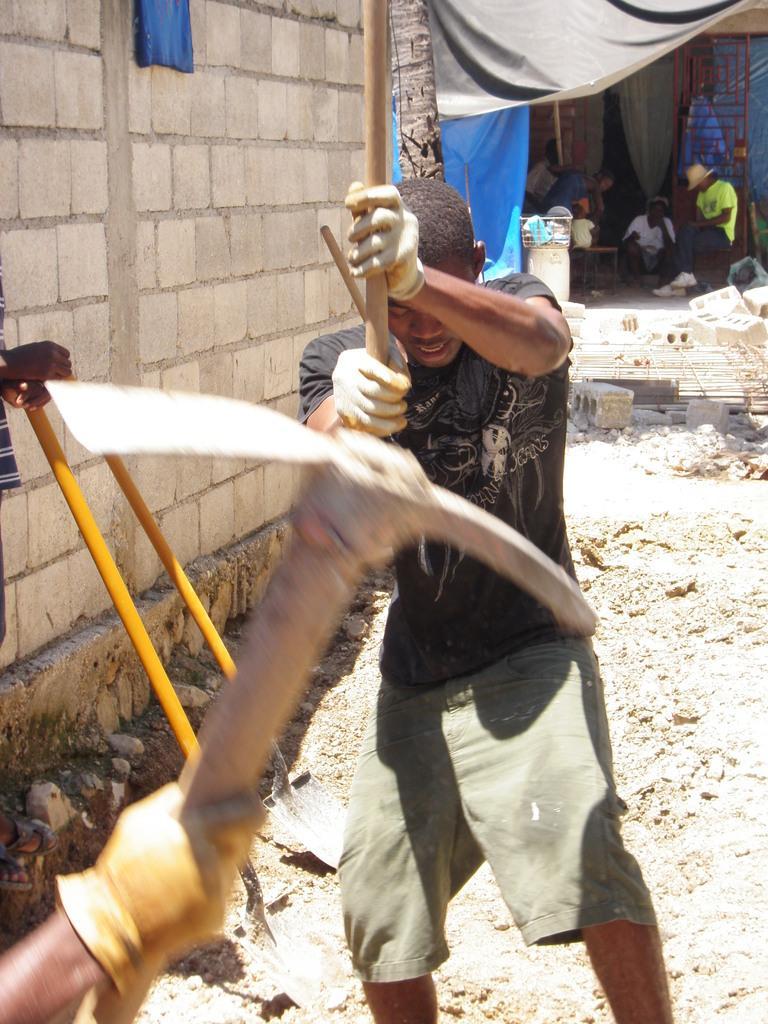Please provide a concise description of this image. In this picture there are three persons in the foreground standing and holding the object. At the back there are group of people sitting under the tent and there is a door and curtain. At the back there is a tree and wall. At the bottom there are stones and there is mud. 